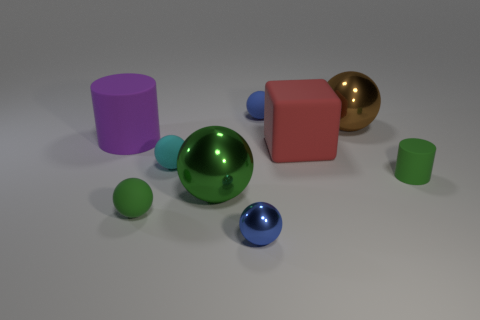What is the size of the rubber sphere that is the same color as the tiny matte cylinder?
Your answer should be very brief. Small. How big is the matte thing in front of the cylinder in front of the large rubber block?
Your answer should be very brief. Small. There is a metallic thing that is behind the large purple object; what is its size?
Ensure brevity in your answer.  Large. Is the number of big brown spheres that are in front of the big purple cylinder less than the number of large matte cubes that are in front of the small cyan object?
Offer a terse response. No. What color is the large rubber cylinder?
Provide a short and direct response. Purple. Are there any big rubber objects of the same color as the matte cube?
Provide a short and direct response. No. The tiny blue thing behind the matte cylinder behind the small matte thing that is right of the big red rubber thing is what shape?
Give a very brief answer. Sphere. There is a blue sphere behind the tiny matte cylinder; what is its material?
Your answer should be compact. Rubber. There is a blue ball that is behind the small matte object that is on the right side of the large shiny object right of the small blue metal ball; what size is it?
Your response must be concise. Small. Is the size of the purple object the same as the blue thing behind the green matte ball?
Provide a succinct answer. No. 